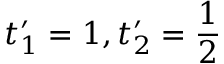<formula> <loc_0><loc_0><loc_500><loc_500>t _ { 1 } ^ { \prime } = 1 , t _ { 2 } ^ { \prime } = \frac { 1 } { 2 }</formula> 